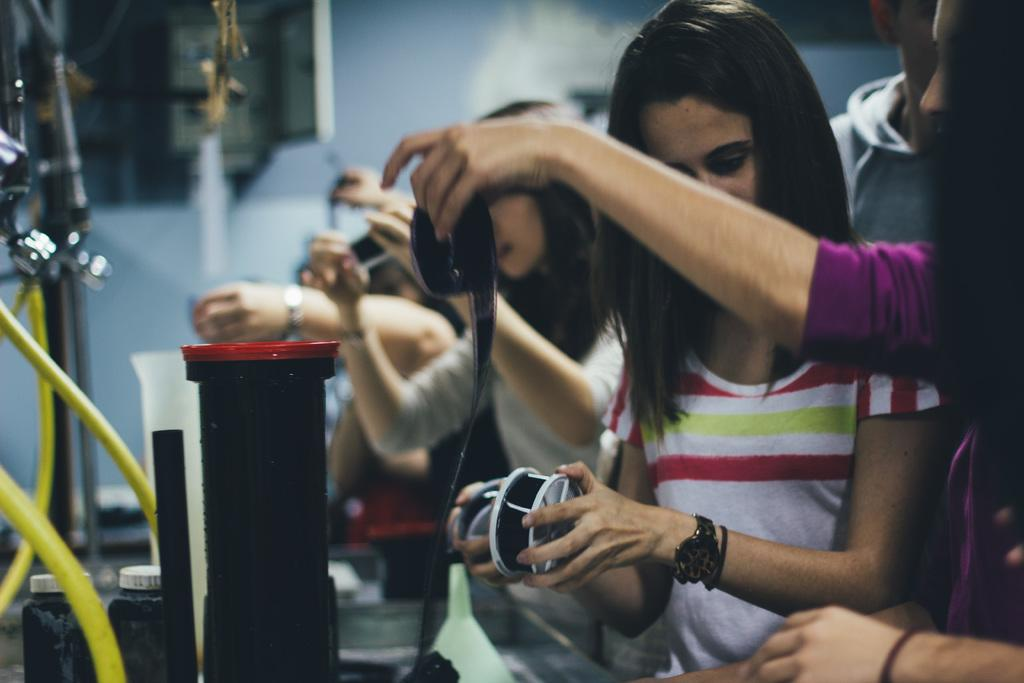How many people are in the image? There is a group of people in the image, but the exact number is not specified. What are the people holding in the image? The people are holding objects, but the specific objects are not mentioned. What type of objects can be seen in the image besides the people? There are pipes, bottles, taps, and measuring jars in the image. What is the background of the image? There is a wall in the image, which serves as the background. What type of sheet is draped over the taps in the image? There is no sheet present in the image; only pipes, bottles, taps, and measuring jars are visible. How many dimes can be seen on the wall in the image? There are no dimes present in the image; only a wall is visible. 